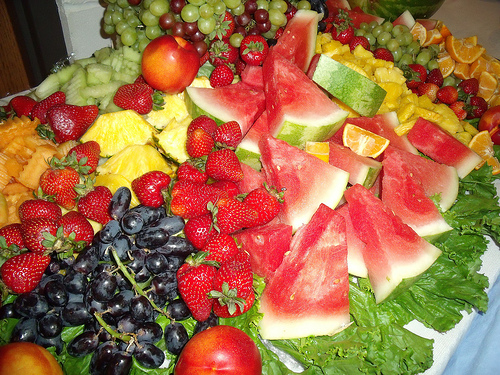<image>
Can you confirm if the watermelon is behind the lettuce? No. The watermelon is not behind the lettuce. From this viewpoint, the watermelon appears to be positioned elsewhere in the scene. 